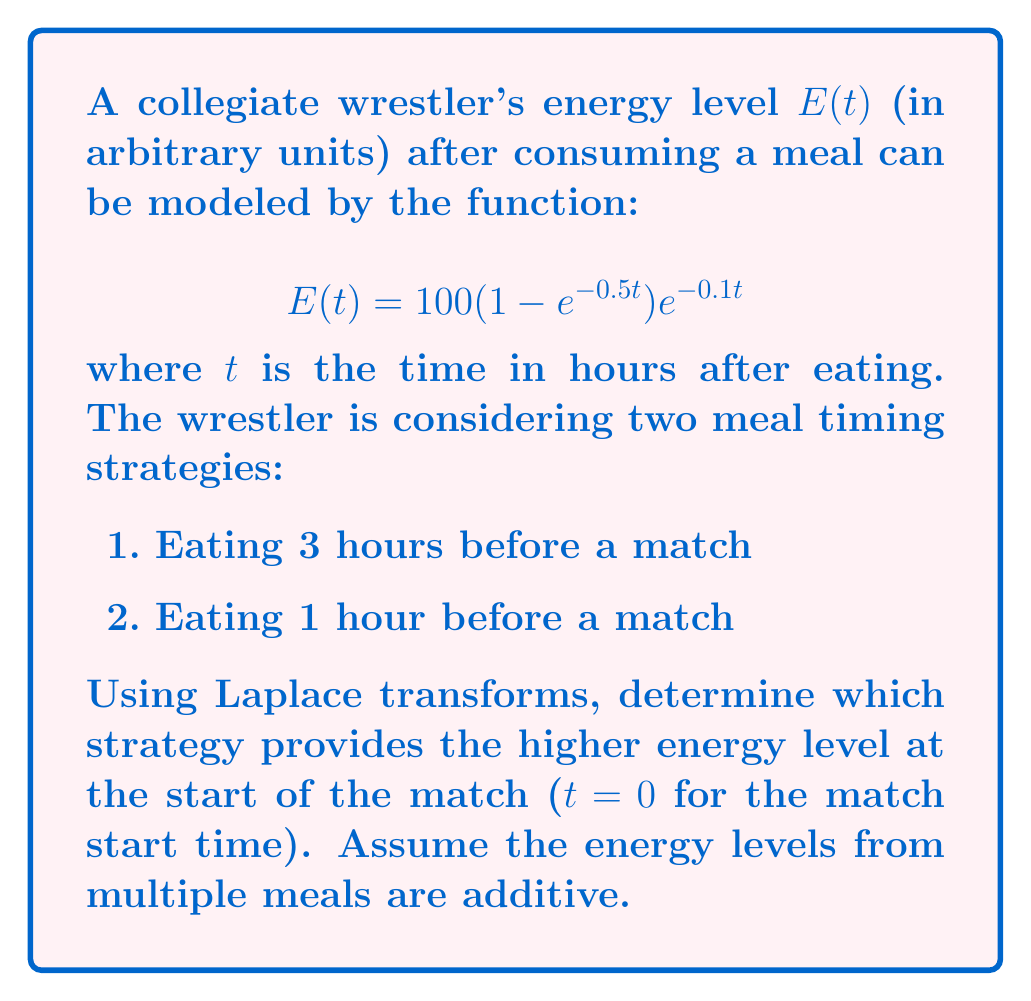Could you help me with this problem? Let's approach this step-by-step using Laplace transforms:

1) First, we need to find the Laplace transform of E(t):

   $$\mathcal{L}\{E(t)\} = \int_0^\infty 100(1 - e^{-0.5t})e^{-0.1t} e^{-st} dt$$

2) This can be simplified to:

   $$E(s) = 100 \left(\frac{1}{s+0.1} - \frac{1}{s+0.6}\right)$$

3) Now, we need to find the energy level at the match start time for each strategy:

   Strategy 1 (3 hours before): $$E_1(s) = E(s)e^{-3s}$$
   Strategy 2 (1 hour before): $$E_2(s) = E(s)e^{-s}$$

4) To find the energy level at t = 0 (match start time), we need to evaluate:

   $$\lim_{s \to \infty} sE_1(s)$$ and $$\lim_{s \to \infty} sE_2(s)$$

5) For Strategy 1:
   
   $$\lim_{s \to \infty} sE_1(s) = \lim_{s \to \infty} 100s \left(\frac{1}{s+0.1} - \frac{1}{s+0.6}\right)e^{-3s} = 0$$

6) For Strategy 2:
   
   $$\lim_{s \to \infty} sE_2(s) = \lim_{s \to \infty} 100s \left(\frac{1}{s+0.1} - \frac{1}{s+0.6}\right)e^{-s} = 0$$

7) Both strategies result in zero energy at the exact start of the match. However, this is due to the instantaneous nature of the Laplace transform. In practice, we should consider a small time ε after the match starts.

8) We can find this by taking the inverse Laplace transform and evaluating at a small positive time:

   $$E_1(t) = 100(1 - e^{-0.5(t+3)})e^{-0.1(t+3)}$$
   $$E_2(t) = 100(1 - e^{-0.5(t+1)})e^{-0.1(t+1)}$$

9) Evaluating at t = ε (where ε is very small):

   $$E_1(ε) ≈ 100(1 - e^{-1.5})e^{-0.3} ≈ 52.76$$
   $$E_2(ε) ≈ 100(1 - e^{-0.5})e^{-0.1} ≈ 34.91$$

Therefore, eating 3 hours before the match provides higher energy levels at the start of the match.
Answer: Eating 3 hours before the match provides higher energy levels. 